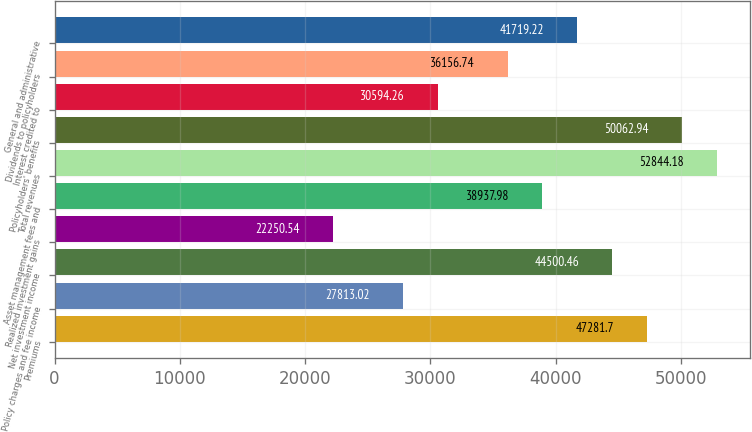Convert chart to OTSL. <chart><loc_0><loc_0><loc_500><loc_500><bar_chart><fcel>Premiums<fcel>Policy charges and fee income<fcel>Net investment income<fcel>Realized investment gains<fcel>Asset management fees and<fcel>Total revenues<fcel>Policyholders' benefits<fcel>Interest credited to<fcel>Dividends to policyholders<fcel>General and administrative<nl><fcel>47281.7<fcel>27813<fcel>44500.5<fcel>22250.5<fcel>38938<fcel>52844.2<fcel>50062.9<fcel>30594.3<fcel>36156.7<fcel>41719.2<nl></chart> 